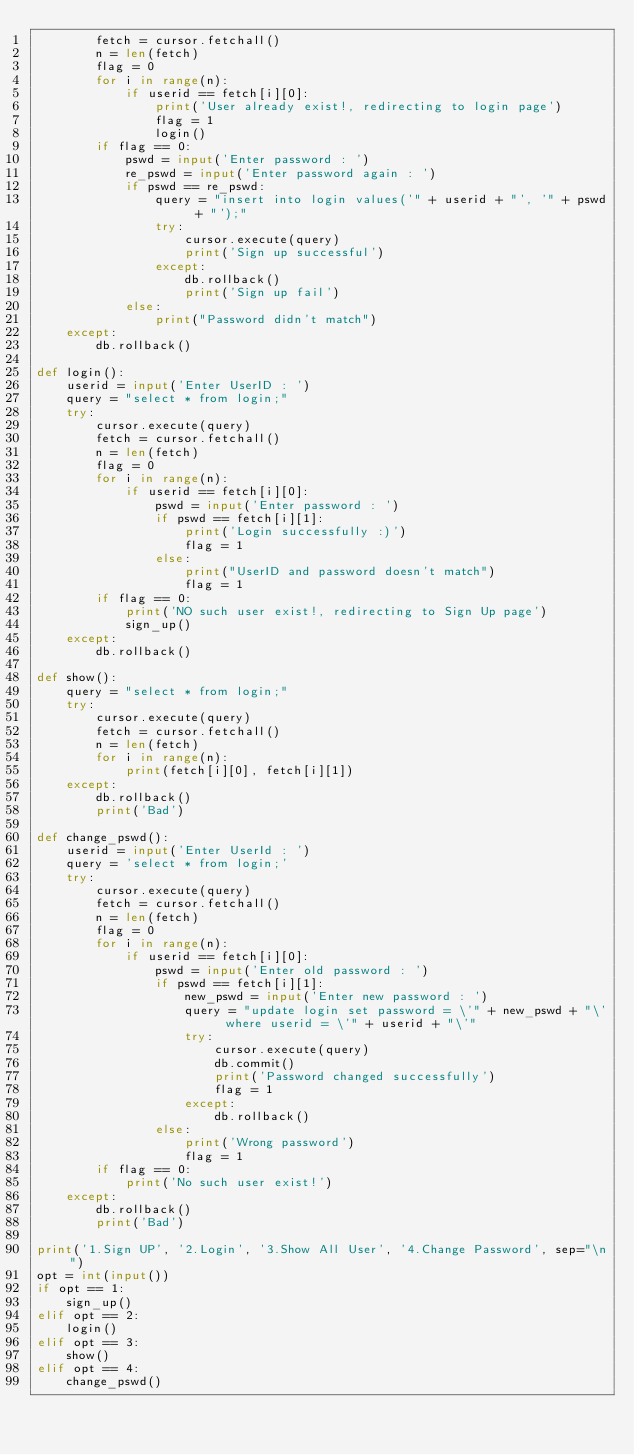<code> <loc_0><loc_0><loc_500><loc_500><_Python_>        fetch = cursor.fetchall()
        n = len(fetch)
        flag = 0
        for i in range(n):
            if userid == fetch[i][0]:
                print('User already exist!, redirecting to login page')
                flag = 1
                login()
        if flag == 0:
            pswd = input('Enter password : ')
            re_pswd = input('Enter password again : ')
            if pswd == re_pswd:
                query = "insert into login values('" + userid + "', '" + pswd + "');"
                try:
                    cursor.execute(query)
                    print('Sign up successful')
                except:
                    db.rollback()
                    print('Sign up fail')
            else:
                print("Password didn't match")
    except:
        db.rollback()

def login():
    userid = input('Enter UserID : ')
    query = "select * from login;"
    try:
        cursor.execute(query)
        fetch = cursor.fetchall()
        n = len(fetch)
        flag = 0
        for i in range(n):
            if userid == fetch[i][0]:
                pswd = input('Enter password : ')
                if pswd == fetch[i][1]:
                    print('Login successfully :)')
                    flag = 1
                else:
                    print("UserID and password doesn't match")
                    flag = 1
        if flag == 0:
            print('NO such user exist!, redirecting to Sign Up page')
            sign_up()
    except:
        db.rollback()

def show():
    query = "select * from login;"
    try:
        cursor.execute(query)
        fetch = cursor.fetchall()
        n = len(fetch)
        for i in range(n):
            print(fetch[i][0], fetch[i][1])
    except:
        db.rollback()
        print('Bad')

def change_pswd():
    userid = input('Enter UserId : ')
    query = 'select * from login;'
    try:
        cursor.execute(query)
        fetch = cursor.fetchall()
        n = len(fetch)
        flag = 0
        for i in range(n):
            if userid == fetch[i][0]:
                pswd = input('Enter old password : ')
                if pswd == fetch[i][1]:
                    new_pswd = input('Enter new password : ')
                    query = "update login set password = \'" + new_pswd + "\' where userid = \'" + userid + "\'"
                    try:
                        cursor.execute(query)
                        db.commit()
                        print('Password changed successfully')
                        flag = 1
                    except:
                        db.rollback()
                else:
                    print('Wrong password')
                    flag = 1
        if flag == 0:
            print('No such user exist!')
    except:
        db.rollback()
        print('Bad')

print('1.Sign UP', '2.Login', '3.Show All User', '4.Change Password', sep="\n")
opt = int(input())
if opt == 1:
    sign_up()
elif opt == 2:
    login()
elif opt == 3:
    show()
elif opt == 4:
    change_pswd()
</code> 